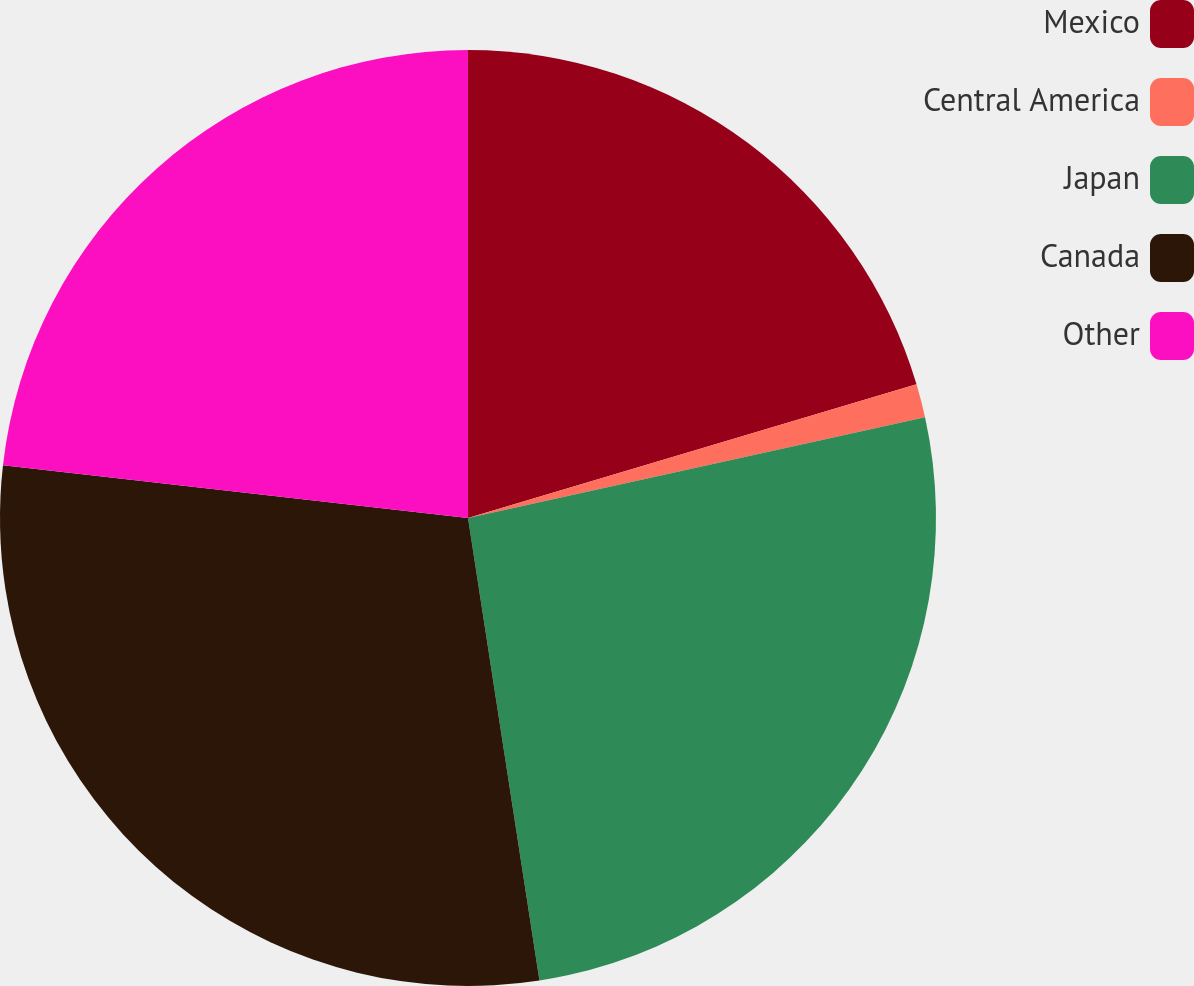Convert chart to OTSL. <chart><loc_0><loc_0><loc_500><loc_500><pie_chart><fcel>Mexico<fcel>Central America<fcel>Japan<fcel>Canada<fcel>Other<nl><fcel>20.39%<fcel>1.16%<fcel>26.01%<fcel>29.24%<fcel>23.2%<nl></chart> 